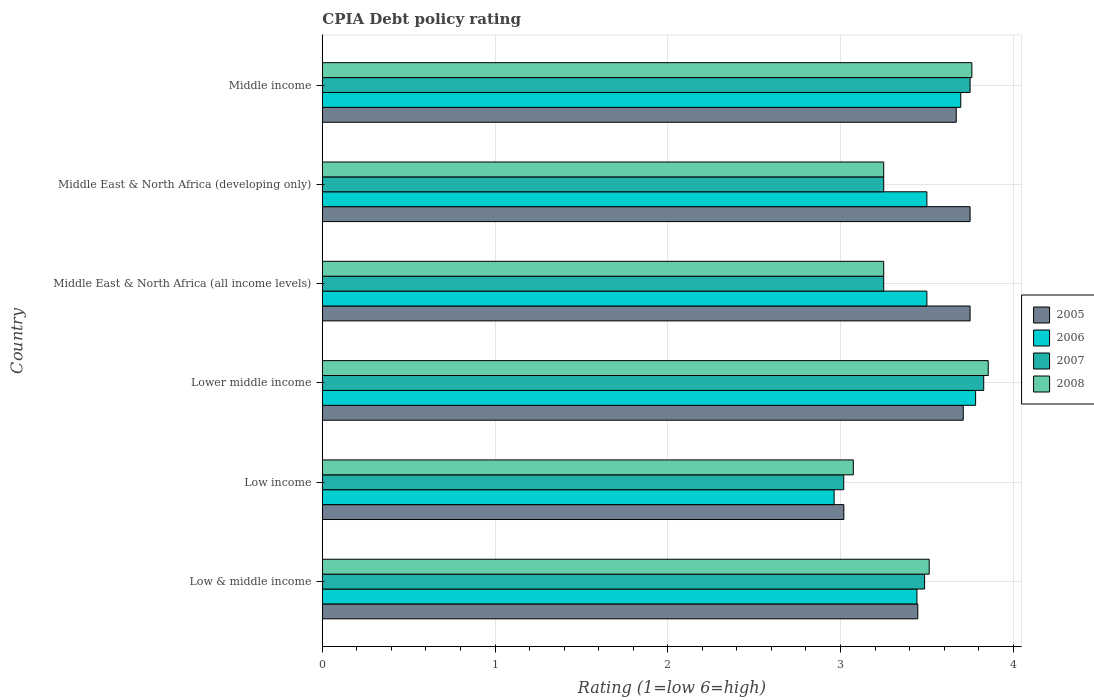How many different coloured bars are there?
Offer a terse response. 4. How many groups of bars are there?
Provide a short and direct response. 6. Are the number of bars per tick equal to the number of legend labels?
Make the answer very short. Yes. How many bars are there on the 2nd tick from the bottom?
Provide a short and direct response. 4. What is the label of the 4th group of bars from the top?
Keep it short and to the point. Lower middle income. What is the CPIA rating in 2005 in Lower middle income?
Keep it short and to the point. 3.71. Across all countries, what is the maximum CPIA rating in 2008?
Ensure brevity in your answer.  3.86. Across all countries, what is the minimum CPIA rating in 2007?
Your answer should be very brief. 3.02. In which country was the CPIA rating in 2008 maximum?
Make the answer very short. Lower middle income. What is the total CPIA rating in 2006 in the graph?
Make the answer very short. 20.88. What is the difference between the CPIA rating in 2007 in Lower middle income and that in Middle East & North Africa (all income levels)?
Your answer should be very brief. 0.58. What is the difference between the CPIA rating in 2005 in Middle East & North Africa (all income levels) and the CPIA rating in 2008 in Low income?
Provide a short and direct response. 0.68. What is the average CPIA rating in 2006 per country?
Provide a short and direct response. 3.48. What is the difference between the CPIA rating in 2007 and CPIA rating in 2008 in Middle East & North Africa (all income levels)?
Your answer should be very brief. 0. What is the ratio of the CPIA rating in 2007 in Low income to that in Middle East & North Africa (all income levels)?
Provide a short and direct response. 0.93. What is the difference between the highest and the second highest CPIA rating in 2005?
Keep it short and to the point. 0. What is the difference between the highest and the lowest CPIA rating in 2007?
Your answer should be very brief. 0.81. In how many countries, is the CPIA rating in 2007 greater than the average CPIA rating in 2007 taken over all countries?
Provide a succinct answer. 3. Is it the case that in every country, the sum of the CPIA rating in 2008 and CPIA rating in 2007 is greater than the CPIA rating in 2006?
Ensure brevity in your answer.  Yes. How many bars are there?
Your answer should be compact. 24. Are all the bars in the graph horizontal?
Provide a succinct answer. Yes. How many countries are there in the graph?
Keep it short and to the point. 6. Are the values on the major ticks of X-axis written in scientific E-notation?
Give a very brief answer. No. Does the graph contain grids?
Offer a very short reply. Yes. Where does the legend appear in the graph?
Make the answer very short. Center right. How many legend labels are there?
Ensure brevity in your answer.  4. How are the legend labels stacked?
Offer a very short reply. Vertical. What is the title of the graph?
Your answer should be compact. CPIA Debt policy rating. Does "2011" appear as one of the legend labels in the graph?
Make the answer very short. No. What is the Rating (1=low 6=high) of 2005 in Low & middle income?
Provide a short and direct response. 3.45. What is the Rating (1=low 6=high) in 2006 in Low & middle income?
Offer a terse response. 3.44. What is the Rating (1=low 6=high) in 2007 in Low & middle income?
Provide a succinct answer. 3.49. What is the Rating (1=low 6=high) in 2008 in Low & middle income?
Keep it short and to the point. 3.51. What is the Rating (1=low 6=high) of 2005 in Low income?
Your response must be concise. 3.02. What is the Rating (1=low 6=high) in 2006 in Low income?
Your answer should be very brief. 2.96. What is the Rating (1=low 6=high) of 2007 in Low income?
Offer a terse response. 3.02. What is the Rating (1=low 6=high) in 2008 in Low income?
Your answer should be very brief. 3.07. What is the Rating (1=low 6=high) of 2005 in Lower middle income?
Keep it short and to the point. 3.71. What is the Rating (1=low 6=high) of 2006 in Lower middle income?
Your answer should be very brief. 3.78. What is the Rating (1=low 6=high) in 2007 in Lower middle income?
Give a very brief answer. 3.83. What is the Rating (1=low 6=high) in 2008 in Lower middle income?
Ensure brevity in your answer.  3.86. What is the Rating (1=low 6=high) in 2005 in Middle East & North Africa (all income levels)?
Provide a short and direct response. 3.75. What is the Rating (1=low 6=high) of 2006 in Middle East & North Africa (all income levels)?
Ensure brevity in your answer.  3.5. What is the Rating (1=low 6=high) in 2007 in Middle East & North Africa (all income levels)?
Make the answer very short. 3.25. What is the Rating (1=low 6=high) of 2008 in Middle East & North Africa (all income levels)?
Give a very brief answer. 3.25. What is the Rating (1=low 6=high) in 2005 in Middle East & North Africa (developing only)?
Offer a very short reply. 3.75. What is the Rating (1=low 6=high) of 2006 in Middle East & North Africa (developing only)?
Keep it short and to the point. 3.5. What is the Rating (1=low 6=high) in 2007 in Middle East & North Africa (developing only)?
Give a very brief answer. 3.25. What is the Rating (1=low 6=high) in 2008 in Middle East & North Africa (developing only)?
Offer a terse response. 3.25. What is the Rating (1=low 6=high) in 2005 in Middle income?
Offer a very short reply. 3.67. What is the Rating (1=low 6=high) of 2006 in Middle income?
Ensure brevity in your answer.  3.7. What is the Rating (1=low 6=high) of 2007 in Middle income?
Offer a very short reply. 3.75. What is the Rating (1=low 6=high) in 2008 in Middle income?
Make the answer very short. 3.76. Across all countries, what is the maximum Rating (1=low 6=high) in 2005?
Your response must be concise. 3.75. Across all countries, what is the maximum Rating (1=low 6=high) of 2006?
Make the answer very short. 3.78. Across all countries, what is the maximum Rating (1=low 6=high) of 2007?
Make the answer very short. 3.83. Across all countries, what is the maximum Rating (1=low 6=high) of 2008?
Your answer should be compact. 3.86. Across all countries, what is the minimum Rating (1=low 6=high) of 2005?
Offer a very short reply. 3.02. Across all countries, what is the minimum Rating (1=low 6=high) in 2006?
Give a very brief answer. 2.96. Across all countries, what is the minimum Rating (1=low 6=high) in 2007?
Your response must be concise. 3.02. Across all countries, what is the minimum Rating (1=low 6=high) of 2008?
Provide a succinct answer. 3.07. What is the total Rating (1=low 6=high) of 2005 in the graph?
Your response must be concise. 21.35. What is the total Rating (1=low 6=high) in 2006 in the graph?
Ensure brevity in your answer.  20.88. What is the total Rating (1=low 6=high) of 2007 in the graph?
Keep it short and to the point. 20.58. What is the total Rating (1=low 6=high) of 2008 in the graph?
Keep it short and to the point. 20.7. What is the difference between the Rating (1=low 6=high) in 2005 in Low & middle income and that in Low income?
Provide a short and direct response. 0.43. What is the difference between the Rating (1=low 6=high) in 2006 in Low & middle income and that in Low income?
Provide a short and direct response. 0.48. What is the difference between the Rating (1=low 6=high) in 2007 in Low & middle income and that in Low income?
Provide a short and direct response. 0.47. What is the difference between the Rating (1=low 6=high) of 2008 in Low & middle income and that in Low income?
Your answer should be compact. 0.44. What is the difference between the Rating (1=low 6=high) of 2005 in Low & middle income and that in Lower middle income?
Keep it short and to the point. -0.26. What is the difference between the Rating (1=low 6=high) in 2006 in Low & middle income and that in Lower middle income?
Your answer should be compact. -0.34. What is the difference between the Rating (1=low 6=high) of 2007 in Low & middle income and that in Lower middle income?
Your answer should be compact. -0.34. What is the difference between the Rating (1=low 6=high) in 2008 in Low & middle income and that in Lower middle income?
Give a very brief answer. -0.34. What is the difference between the Rating (1=low 6=high) in 2005 in Low & middle income and that in Middle East & North Africa (all income levels)?
Provide a succinct answer. -0.3. What is the difference between the Rating (1=low 6=high) in 2006 in Low & middle income and that in Middle East & North Africa (all income levels)?
Offer a very short reply. -0.06. What is the difference between the Rating (1=low 6=high) in 2007 in Low & middle income and that in Middle East & North Africa (all income levels)?
Your answer should be compact. 0.24. What is the difference between the Rating (1=low 6=high) in 2008 in Low & middle income and that in Middle East & North Africa (all income levels)?
Your answer should be compact. 0.26. What is the difference between the Rating (1=low 6=high) of 2005 in Low & middle income and that in Middle East & North Africa (developing only)?
Offer a terse response. -0.3. What is the difference between the Rating (1=low 6=high) of 2006 in Low & middle income and that in Middle East & North Africa (developing only)?
Your answer should be compact. -0.06. What is the difference between the Rating (1=low 6=high) of 2007 in Low & middle income and that in Middle East & North Africa (developing only)?
Offer a very short reply. 0.24. What is the difference between the Rating (1=low 6=high) of 2008 in Low & middle income and that in Middle East & North Africa (developing only)?
Provide a succinct answer. 0.26. What is the difference between the Rating (1=low 6=high) in 2005 in Low & middle income and that in Middle income?
Your answer should be compact. -0.22. What is the difference between the Rating (1=low 6=high) in 2006 in Low & middle income and that in Middle income?
Ensure brevity in your answer.  -0.25. What is the difference between the Rating (1=low 6=high) of 2007 in Low & middle income and that in Middle income?
Your response must be concise. -0.26. What is the difference between the Rating (1=low 6=high) in 2008 in Low & middle income and that in Middle income?
Provide a short and direct response. -0.25. What is the difference between the Rating (1=low 6=high) of 2005 in Low income and that in Lower middle income?
Ensure brevity in your answer.  -0.69. What is the difference between the Rating (1=low 6=high) in 2006 in Low income and that in Lower middle income?
Offer a terse response. -0.82. What is the difference between the Rating (1=low 6=high) of 2007 in Low income and that in Lower middle income?
Give a very brief answer. -0.81. What is the difference between the Rating (1=low 6=high) in 2008 in Low income and that in Lower middle income?
Your answer should be very brief. -0.78. What is the difference between the Rating (1=low 6=high) in 2005 in Low income and that in Middle East & North Africa (all income levels)?
Give a very brief answer. -0.73. What is the difference between the Rating (1=low 6=high) in 2006 in Low income and that in Middle East & North Africa (all income levels)?
Ensure brevity in your answer.  -0.54. What is the difference between the Rating (1=low 6=high) in 2007 in Low income and that in Middle East & North Africa (all income levels)?
Your answer should be very brief. -0.23. What is the difference between the Rating (1=low 6=high) of 2008 in Low income and that in Middle East & North Africa (all income levels)?
Your answer should be very brief. -0.18. What is the difference between the Rating (1=low 6=high) in 2005 in Low income and that in Middle East & North Africa (developing only)?
Provide a succinct answer. -0.73. What is the difference between the Rating (1=low 6=high) of 2006 in Low income and that in Middle East & North Africa (developing only)?
Your response must be concise. -0.54. What is the difference between the Rating (1=low 6=high) in 2007 in Low income and that in Middle East & North Africa (developing only)?
Keep it short and to the point. -0.23. What is the difference between the Rating (1=low 6=high) in 2008 in Low income and that in Middle East & North Africa (developing only)?
Offer a very short reply. -0.18. What is the difference between the Rating (1=low 6=high) in 2005 in Low income and that in Middle income?
Provide a short and direct response. -0.65. What is the difference between the Rating (1=low 6=high) of 2006 in Low income and that in Middle income?
Make the answer very short. -0.73. What is the difference between the Rating (1=low 6=high) of 2007 in Low income and that in Middle income?
Provide a succinct answer. -0.73. What is the difference between the Rating (1=low 6=high) in 2008 in Low income and that in Middle income?
Your answer should be compact. -0.69. What is the difference between the Rating (1=low 6=high) of 2005 in Lower middle income and that in Middle East & North Africa (all income levels)?
Make the answer very short. -0.04. What is the difference between the Rating (1=low 6=high) of 2006 in Lower middle income and that in Middle East & North Africa (all income levels)?
Keep it short and to the point. 0.28. What is the difference between the Rating (1=low 6=high) of 2007 in Lower middle income and that in Middle East & North Africa (all income levels)?
Your answer should be very brief. 0.58. What is the difference between the Rating (1=low 6=high) of 2008 in Lower middle income and that in Middle East & North Africa (all income levels)?
Offer a very short reply. 0.61. What is the difference between the Rating (1=low 6=high) in 2005 in Lower middle income and that in Middle East & North Africa (developing only)?
Your response must be concise. -0.04. What is the difference between the Rating (1=low 6=high) in 2006 in Lower middle income and that in Middle East & North Africa (developing only)?
Provide a succinct answer. 0.28. What is the difference between the Rating (1=low 6=high) of 2007 in Lower middle income and that in Middle East & North Africa (developing only)?
Make the answer very short. 0.58. What is the difference between the Rating (1=low 6=high) in 2008 in Lower middle income and that in Middle East & North Africa (developing only)?
Keep it short and to the point. 0.61. What is the difference between the Rating (1=low 6=high) of 2005 in Lower middle income and that in Middle income?
Ensure brevity in your answer.  0.04. What is the difference between the Rating (1=low 6=high) of 2006 in Lower middle income and that in Middle income?
Provide a short and direct response. 0.09. What is the difference between the Rating (1=low 6=high) in 2007 in Lower middle income and that in Middle income?
Keep it short and to the point. 0.08. What is the difference between the Rating (1=low 6=high) in 2008 in Lower middle income and that in Middle income?
Make the answer very short. 0.09. What is the difference between the Rating (1=low 6=high) in 2005 in Middle East & North Africa (all income levels) and that in Middle East & North Africa (developing only)?
Your answer should be compact. 0. What is the difference between the Rating (1=low 6=high) in 2008 in Middle East & North Africa (all income levels) and that in Middle East & North Africa (developing only)?
Your response must be concise. 0. What is the difference between the Rating (1=low 6=high) in 2005 in Middle East & North Africa (all income levels) and that in Middle income?
Give a very brief answer. 0.08. What is the difference between the Rating (1=low 6=high) of 2006 in Middle East & North Africa (all income levels) and that in Middle income?
Provide a short and direct response. -0.2. What is the difference between the Rating (1=low 6=high) in 2007 in Middle East & North Africa (all income levels) and that in Middle income?
Provide a short and direct response. -0.5. What is the difference between the Rating (1=low 6=high) of 2008 in Middle East & North Africa (all income levels) and that in Middle income?
Ensure brevity in your answer.  -0.51. What is the difference between the Rating (1=low 6=high) of 2006 in Middle East & North Africa (developing only) and that in Middle income?
Your answer should be compact. -0.2. What is the difference between the Rating (1=low 6=high) in 2007 in Middle East & North Africa (developing only) and that in Middle income?
Keep it short and to the point. -0.5. What is the difference between the Rating (1=low 6=high) in 2008 in Middle East & North Africa (developing only) and that in Middle income?
Offer a very short reply. -0.51. What is the difference between the Rating (1=low 6=high) in 2005 in Low & middle income and the Rating (1=low 6=high) in 2006 in Low income?
Make the answer very short. 0.48. What is the difference between the Rating (1=low 6=high) in 2005 in Low & middle income and the Rating (1=low 6=high) in 2007 in Low income?
Provide a short and direct response. 0.43. What is the difference between the Rating (1=low 6=high) in 2005 in Low & middle income and the Rating (1=low 6=high) in 2008 in Low income?
Your answer should be very brief. 0.37. What is the difference between the Rating (1=low 6=high) of 2006 in Low & middle income and the Rating (1=low 6=high) of 2007 in Low income?
Your answer should be very brief. 0.42. What is the difference between the Rating (1=low 6=high) of 2006 in Low & middle income and the Rating (1=low 6=high) of 2008 in Low income?
Provide a short and direct response. 0.37. What is the difference between the Rating (1=low 6=high) of 2007 in Low & middle income and the Rating (1=low 6=high) of 2008 in Low income?
Give a very brief answer. 0.41. What is the difference between the Rating (1=low 6=high) of 2005 in Low & middle income and the Rating (1=low 6=high) of 2006 in Lower middle income?
Your answer should be compact. -0.33. What is the difference between the Rating (1=low 6=high) of 2005 in Low & middle income and the Rating (1=low 6=high) of 2007 in Lower middle income?
Give a very brief answer. -0.38. What is the difference between the Rating (1=low 6=high) in 2005 in Low & middle income and the Rating (1=low 6=high) in 2008 in Lower middle income?
Offer a very short reply. -0.41. What is the difference between the Rating (1=low 6=high) of 2006 in Low & middle income and the Rating (1=low 6=high) of 2007 in Lower middle income?
Keep it short and to the point. -0.39. What is the difference between the Rating (1=low 6=high) in 2006 in Low & middle income and the Rating (1=low 6=high) in 2008 in Lower middle income?
Your response must be concise. -0.41. What is the difference between the Rating (1=low 6=high) in 2007 in Low & middle income and the Rating (1=low 6=high) in 2008 in Lower middle income?
Offer a terse response. -0.37. What is the difference between the Rating (1=low 6=high) of 2005 in Low & middle income and the Rating (1=low 6=high) of 2006 in Middle East & North Africa (all income levels)?
Provide a succinct answer. -0.05. What is the difference between the Rating (1=low 6=high) of 2005 in Low & middle income and the Rating (1=low 6=high) of 2007 in Middle East & North Africa (all income levels)?
Make the answer very short. 0.2. What is the difference between the Rating (1=low 6=high) in 2005 in Low & middle income and the Rating (1=low 6=high) in 2008 in Middle East & North Africa (all income levels)?
Provide a succinct answer. 0.2. What is the difference between the Rating (1=low 6=high) in 2006 in Low & middle income and the Rating (1=low 6=high) in 2007 in Middle East & North Africa (all income levels)?
Provide a short and direct response. 0.19. What is the difference between the Rating (1=low 6=high) of 2006 in Low & middle income and the Rating (1=low 6=high) of 2008 in Middle East & North Africa (all income levels)?
Provide a short and direct response. 0.19. What is the difference between the Rating (1=low 6=high) in 2007 in Low & middle income and the Rating (1=low 6=high) in 2008 in Middle East & North Africa (all income levels)?
Make the answer very short. 0.24. What is the difference between the Rating (1=low 6=high) in 2005 in Low & middle income and the Rating (1=low 6=high) in 2006 in Middle East & North Africa (developing only)?
Your response must be concise. -0.05. What is the difference between the Rating (1=low 6=high) of 2005 in Low & middle income and the Rating (1=low 6=high) of 2007 in Middle East & North Africa (developing only)?
Your answer should be very brief. 0.2. What is the difference between the Rating (1=low 6=high) of 2005 in Low & middle income and the Rating (1=low 6=high) of 2008 in Middle East & North Africa (developing only)?
Offer a terse response. 0.2. What is the difference between the Rating (1=low 6=high) in 2006 in Low & middle income and the Rating (1=low 6=high) in 2007 in Middle East & North Africa (developing only)?
Your answer should be compact. 0.19. What is the difference between the Rating (1=low 6=high) in 2006 in Low & middle income and the Rating (1=low 6=high) in 2008 in Middle East & North Africa (developing only)?
Keep it short and to the point. 0.19. What is the difference between the Rating (1=low 6=high) of 2007 in Low & middle income and the Rating (1=low 6=high) of 2008 in Middle East & North Africa (developing only)?
Offer a very short reply. 0.24. What is the difference between the Rating (1=low 6=high) in 2005 in Low & middle income and the Rating (1=low 6=high) in 2006 in Middle income?
Provide a succinct answer. -0.25. What is the difference between the Rating (1=low 6=high) in 2005 in Low & middle income and the Rating (1=low 6=high) in 2007 in Middle income?
Provide a short and direct response. -0.3. What is the difference between the Rating (1=low 6=high) in 2005 in Low & middle income and the Rating (1=low 6=high) in 2008 in Middle income?
Ensure brevity in your answer.  -0.31. What is the difference between the Rating (1=low 6=high) of 2006 in Low & middle income and the Rating (1=low 6=high) of 2007 in Middle income?
Your response must be concise. -0.31. What is the difference between the Rating (1=low 6=high) in 2006 in Low & middle income and the Rating (1=low 6=high) in 2008 in Middle income?
Make the answer very short. -0.32. What is the difference between the Rating (1=low 6=high) of 2007 in Low & middle income and the Rating (1=low 6=high) of 2008 in Middle income?
Your answer should be compact. -0.27. What is the difference between the Rating (1=low 6=high) of 2005 in Low income and the Rating (1=low 6=high) of 2006 in Lower middle income?
Make the answer very short. -0.76. What is the difference between the Rating (1=low 6=high) in 2005 in Low income and the Rating (1=low 6=high) in 2007 in Lower middle income?
Keep it short and to the point. -0.81. What is the difference between the Rating (1=low 6=high) in 2005 in Low income and the Rating (1=low 6=high) in 2008 in Lower middle income?
Your answer should be very brief. -0.84. What is the difference between the Rating (1=low 6=high) in 2006 in Low income and the Rating (1=low 6=high) in 2007 in Lower middle income?
Your answer should be compact. -0.87. What is the difference between the Rating (1=low 6=high) in 2006 in Low income and the Rating (1=low 6=high) in 2008 in Lower middle income?
Make the answer very short. -0.89. What is the difference between the Rating (1=low 6=high) in 2007 in Low income and the Rating (1=low 6=high) in 2008 in Lower middle income?
Provide a short and direct response. -0.84. What is the difference between the Rating (1=low 6=high) of 2005 in Low income and the Rating (1=low 6=high) of 2006 in Middle East & North Africa (all income levels)?
Give a very brief answer. -0.48. What is the difference between the Rating (1=low 6=high) in 2005 in Low income and the Rating (1=low 6=high) in 2007 in Middle East & North Africa (all income levels)?
Your response must be concise. -0.23. What is the difference between the Rating (1=low 6=high) in 2005 in Low income and the Rating (1=low 6=high) in 2008 in Middle East & North Africa (all income levels)?
Provide a short and direct response. -0.23. What is the difference between the Rating (1=low 6=high) in 2006 in Low income and the Rating (1=low 6=high) in 2007 in Middle East & North Africa (all income levels)?
Ensure brevity in your answer.  -0.29. What is the difference between the Rating (1=low 6=high) of 2006 in Low income and the Rating (1=low 6=high) of 2008 in Middle East & North Africa (all income levels)?
Offer a very short reply. -0.29. What is the difference between the Rating (1=low 6=high) of 2007 in Low income and the Rating (1=low 6=high) of 2008 in Middle East & North Africa (all income levels)?
Your answer should be very brief. -0.23. What is the difference between the Rating (1=low 6=high) in 2005 in Low income and the Rating (1=low 6=high) in 2006 in Middle East & North Africa (developing only)?
Offer a terse response. -0.48. What is the difference between the Rating (1=low 6=high) of 2005 in Low income and the Rating (1=low 6=high) of 2007 in Middle East & North Africa (developing only)?
Your response must be concise. -0.23. What is the difference between the Rating (1=low 6=high) in 2005 in Low income and the Rating (1=low 6=high) in 2008 in Middle East & North Africa (developing only)?
Offer a very short reply. -0.23. What is the difference between the Rating (1=low 6=high) in 2006 in Low income and the Rating (1=low 6=high) in 2007 in Middle East & North Africa (developing only)?
Your answer should be very brief. -0.29. What is the difference between the Rating (1=low 6=high) in 2006 in Low income and the Rating (1=low 6=high) in 2008 in Middle East & North Africa (developing only)?
Your answer should be very brief. -0.29. What is the difference between the Rating (1=low 6=high) of 2007 in Low income and the Rating (1=low 6=high) of 2008 in Middle East & North Africa (developing only)?
Offer a very short reply. -0.23. What is the difference between the Rating (1=low 6=high) of 2005 in Low income and the Rating (1=low 6=high) of 2006 in Middle income?
Give a very brief answer. -0.68. What is the difference between the Rating (1=low 6=high) of 2005 in Low income and the Rating (1=low 6=high) of 2007 in Middle income?
Ensure brevity in your answer.  -0.73. What is the difference between the Rating (1=low 6=high) of 2005 in Low income and the Rating (1=low 6=high) of 2008 in Middle income?
Your answer should be very brief. -0.74. What is the difference between the Rating (1=low 6=high) of 2006 in Low income and the Rating (1=low 6=high) of 2007 in Middle income?
Provide a short and direct response. -0.79. What is the difference between the Rating (1=low 6=high) in 2006 in Low income and the Rating (1=low 6=high) in 2008 in Middle income?
Make the answer very short. -0.8. What is the difference between the Rating (1=low 6=high) of 2007 in Low income and the Rating (1=low 6=high) of 2008 in Middle income?
Offer a very short reply. -0.74. What is the difference between the Rating (1=low 6=high) of 2005 in Lower middle income and the Rating (1=low 6=high) of 2006 in Middle East & North Africa (all income levels)?
Give a very brief answer. 0.21. What is the difference between the Rating (1=low 6=high) in 2005 in Lower middle income and the Rating (1=low 6=high) in 2007 in Middle East & North Africa (all income levels)?
Make the answer very short. 0.46. What is the difference between the Rating (1=low 6=high) in 2005 in Lower middle income and the Rating (1=low 6=high) in 2008 in Middle East & North Africa (all income levels)?
Provide a short and direct response. 0.46. What is the difference between the Rating (1=low 6=high) in 2006 in Lower middle income and the Rating (1=low 6=high) in 2007 in Middle East & North Africa (all income levels)?
Your answer should be very brief. 0.53. What is the difference between the Rating (1=low 6=high) of 2006 in Lower middle income and the Rating (1=low 6=high) of 2008 in Middle East & North Africa (all income levels)?
Your response must be concise. 0.53. What is the difference between the Rating (1=low 6=high) of 2007 in Lower middle income and the Rating (1=low 6=high) of 2008 in Middle East & North Africa (all income levels)?
Keep it short and to the point. 0.58. What is the difference between the Rating (1=low 6=high) in 2005 in Lower middle income and the Rating (1=low 6=high) in 2006 in Middle East & North Africa (developing only)?
Give a very brief answer. 0.21. What is the difference between the Rating (1=low 6=high) in 2005 in Lower middle income and the Rating (1=low 6=high) in 2007 in Middle East & North Africa (developing only)?
Keep it short and to the point. 0.46. What is the difference between the Rating (1=low 6=high) in 2005 in Lower middle income and the Rating (1=low 6=high) in 2008 in Middle East & North Africa (developing only)?
Offer a terse response. 0.46. What is the difference between the Rating (1=low 6=high) of 2006 in Lower middle income and the Rating (1=low 6=high) of 2007 in Middle East & North Africa (developing only)?
Your response must be concise. 0.53. What is the difference between the Rating (1=low 6=high) in 2006 in Lower middle income and the Rating (1=low 6=high) in 2008 in Middle East & North Africa (developing only)?
Offer a very short reply. 0.53. What is the difference between the Rating (1=low 6=high) of 2007 in Lower middle income and the Rating (1=low 6=high) of 2008 in Middle East & North Africa (developing only)?
Keep it short and to the point. 0.58. What is the difference between the Rating (1=low 6=high) of 2005 in Lower middle income and the Rating (1=low 6=high) of 2006 in Middle income?
Your response must be concise. 0.01. What is the difference between the Rating (1=low 6=high) of 2005 in Lower middle income and the Rating (1=low 6=high) of 2007 in Middle income?
Your answer should be very brief. -0.04. What is the difference between the Rating (1=low 6=high) in 2005 in Lower middle income and the Rating (1=low 6=high) in 2008 in Middle income?
Your answer should be compact. -0.05. What is the difference between the Rating (1=low 6=high) in 2006 in Lower middle income and the Rating (1=low 6=high) in 2007 in Middle income?
Ensure brevity in your answer.  0.03. What is the difference between the Rating (1=low 6=high) in 2006 in Lower middle income and the Rating (1=low 6=high) in 2008 in Middle income?
Your answer should be compact. 0.02. What is the difference between the Rating (1=low 6=high) of 2007 in Lower middle income and the Rating (1=low 6=high) of 2008 in Middle income?
Your answer should be compact. 0.07. What is the difference between the Rating (1=low 6=high) of 2005 in Middle East & North Africa (all income levels) and the Rating (1=low 6=high) of 2008 in Middle East & North Africa (developing only)?
Ensure brevity in your answer.  0.5. What is the difference between the Rating (1=low 6=high) of 2005 in Middle East & North Africa (all income levels) and the Rating (1=low 6=high) of 2006 in Middle income?
Provide a succinct answer. 0.05. What is the difference between the Rating (1=low 6=high) of 2005 in Middle East & North Africa (all income levels) and the Rating (1=low 6=high) of 2008 in Middle income?
Make the answer very short. -0.01. What is the difference between the Rating (1=low 6=high) of 2006 in Middle East & North Africa (all income levels) and the Rating (1=low 6=high) of 2008 in Middle income?
Offer a terse response. -0.26. What is the difference between the Rating (1=low 6=high) of 2007 in Middle East & North Africa (all income levels) and the Rating (1=low 6=high) of 2008 in Middle income?
Give a very brief answer. -0.51. What is the difference between the Rating (1=low 6=high) of 2005 in Middle East & North Africa (developing only) and the Rating (1=low 6=high) of 2006 in Middle income?
Ensure brevity in your answer.  0.05. What is the difference between the Rating (1=low 6=high) in 2005 in Middle East & North Africa (developing only) and the Rating (1=low 6=high) in 2008 in Middle income?
Your response must be concise. -0.01. What is the difference between the Rating (1=low 6=high) of 2006 in Middle East & North Africa (developing only) and the Rating (1=low 6=high) of 2008 in Middle income?
Provide a succinct answer. -0.26. What is the difference between the Rating (1=low 6=high) in 2007 in Middle East & North Africa (developing only) and the Rating (1=low 6=high) in 2008 in Middle income?
Make the answer very short. -0.51. What is the average Rating (1=low 6=high) of 2005 per country?
Make the answer very short. 3.56. What is the average Rating (1=low 6=high) of 2006 per country?
Make the answer very short. 3.48. What is the average Rating (1=low 6=high) in 2007 per country?
Provide a short and direct response. 3.43. What is the average Rating (1=low 6=high) of 2008 per country?
Your answer should be compact. 3.45. What is the difference between the Rating (1=low 6=high) of 2005 and Rating (1=low 6=high) of 2006 in Low & middle income?
Provide a short and direct response. 0.01. What is the difference between the Rating (1=low 6=high) of 2005 and Rating (1=low 6=high) of 2007 in Low & middle income?
Give a very brief answer. -0.04. What is the difference between the Rating (1=low 6=high) of 2005 and Rating (1=low 6=high) of 2008 in Low & middle income?
Give a very brief answer. -0.07. What is the difference between the Rating (1=low 6=high) in 2006 and Rating (1=low 6=high) in 2007 in Low & middle income?
Your answer should be compact. -0.04. What is the difference between the Rating (1=low 6=high) of 2006 and Rating (1=low 6=high) of 2008 in Low & middle income?
Keep it short and to the point. -0.07. What is the difference between the Rating (1=low 6=high) of 2007 and Rating (1=low 6=high) of 2008 in Low & middle income?
Provide a succinct answer. -0.03. What is the difference between the Rating (1=low 6=high) of 2005 and Rating (1=low 6=high) of 2006 in Low income?
Your response must be concise. 0.06. What is the difference between the Rating (1=low 6=high) of 2005 and Rating (1=low 6=high) of 2007 in Low income?
Provide a succinct answer. 0. What is the difference between the Rating (1=low 6=high) of 2005 and Rating (1=low 6=high) of 2008 in Low income?
Your response must be concise. -0.05. What is the difference between the Rating (1=low 6=high) in 2006 and Rating (1=low 6=high) in 2007 in Low income?
Your answer should be compact. -0.06. What is the difference between the Rating (1=low 6=high) of 2006 and Rating (1=low 6=high) of 2008 in Low income?
Your answer should be very brief. -0.11. What is the difference between the Rating (1=low 6=high) in 2007 and Rating (1=low 6=high) in 2008 in Low income?
Ensure brevity in your answer.  -0.06. What is the difference between the Rating (1=low 6=high) of 2005 and Rating (1=low 6=high) of 2006 in Lower middle income?
Make the answer very short. -0.07. What is the difference between the Rating (1=low 6=high) in 2005 and Rating (1=low 6=high) in 2007 in Lower middle income?
Your answer should be compact. -0.12. What is the difference between the Rating (1=low 6=high) in 2005 and Rating (1=low 6=high) in 2008 in Lower middle income?
Offer a terse response. -0.14. What is the difference between the Rating (1=low 6=high) in 2006 and Rating (1=low 6=high) in 2007 in Lower middle income?
Ensure brevity in your answer.  -0.05. What is the difference between the Rating (1=low 6=high) of 2006 and Rating (1=low 6=high) of 2008 in Lower middle income?
Ensure brevity in your answer.  -0.07. What is the difference between the Rating (1=low 6=high) of 2007 and Rating (1=low 6=high) of 2008 in Lower middle income?
Provide a short and direct response. -0.03. What is the difference between the Rating (1=low 6=high) of 2005 and Rating (1=low 6=high) of 2008 in Middle East & North Africa (all income levels)?
Make the answer very short. 0.5. What is the difference between the Rating (1=low 6=high) of 2005 and Rating (1=low 6=high) of 2006 in Middle East & North Africa (developing only)?
Your response must be concise. 0.25. What is the difference between the Rating (1=low 6=high) of 2005 and Rating (1=low 6=high) of 2007 in Middle East & North Africa (developing only)?
Your answer should be compact. 0.5. What is the difference between the Rating (1=low 6=high) of 2007 and Rating (1=low 6=high) of 2008 in Middle East & North Africa (developing only)?
Make the answer very short. 0. What is the difference between the Rating (1=low 6=high) in 2005 and Rating (1=low 6=high) in 2006 in Middle income?
Give a very brief answer. -0.03. What is the difference between the Rating (1=low 6=high) in 2005 and Rating (1=low 6=high) in 2007 in Middle income?
Keep it short and to the point. -0.08. What is the difference between the Rating (1=low 6=high) in 2005 and Rating (1=low 6=high) in 2008 in Middle income?
Make the answer very short. -0.09. What is the difference between the Rating (1=low 6=high) in 2006 and Rating (1=low 6=high) in 2007 in Middle income?
Keep it short and to the point. -0.05. What is the difference between the Rating (1=low 6=high) in 2006 and Rating (1=low 6=high) in 2008 in Middle income?
Provide a short and direct response. -0.06. What is the difference between the Rating (1=low 6=high) of 2007 and Rating (1=low 6=high) of 2008 in Middle income?
Make the answer very short. -0.01. What is the ratio of the Rating (1=low 6=high) in 2005 in Low & middle income to that in Low income?
Ensure brevity in your answer.  1.14. What is the ratio of the Rating (1=low 6=high) of 2006 in Low & middle income to that in Low income?
Offer a terse response. 1.16. What is the ratio of the Rating (1=low 6=high) in 2007 in Low & middle income to that in Low income?
Keep it short and to the point. 1.16. What is the ratio of the Rating (1=low 6=high) of 2005 in Low & middle income to that in Lower middle income?
Your answer should be compact. 0.93. What is the ratio of the Rating (1=low 6=high) in 2006 in Low & middle income to that in Lower middle income?
Keep it short and to the point. 0.91. What is the ratio of the Rating (1=low 6=high) of 2007 in Low & middle income to that in Lower middle income?
Provide a short and direct response. 0.91. What is the ratio of the Rating (1=low 6=high) in 2008 in Low & middle income to that in Lower middle income?
Provide a short and direct response. 0.91. What is the ratio of the Rating (1=low 6=high) of 2005 in Low & middle income to that in Middle East & North Africa (all income levels)?
Provide a short and direct response. 0.92. What is the ratio of the Rating (1=low 6=high) in 2006 in Low & middle income to that in Middle East & North Africa (all income levels)?
Your answer should be very brief. 0.98. What is the ratio of the Rating (1=low 6=high) of 2007 in Low & middle income to that in Middle East & North Africa (all income levels)?
Your response must be concise. 1.07. What is the ratio of the Rating (1=low 6=high) in 2008 in Low & middle income to that in Middle East & North Africa (all income levels)?
Offer a very short reply. 1.08. What is the ratio of the Rating (1=low 6=high) in 2005 in Low & middle income to that in Middle East & North Africa (developing only)?
Offer a very short reply. 0.92. What is the ratio of the Rating (1=low 6=high) in 2006 in Low & middle income to that in Middle East & North Africa (developing only)?
Provide a succinct answer. 0.98. What is the ratio of the Rating (1=low 6=high) of 2007 in Low & middle income to that in Middle East & North Africa (developing only)?
Your response must be concise. 1.07. What is the ratio of the Rating (1=low 6=high) in 2008 in Low & middle income to that in Middle East & North Africa (developing only)?
Your response must be concise. 1.08. What is the ratio of the Rating (1=low 6=high) of 2005 in Low & middle income to that in Middle income?
Offer a very short reply. 0.94. What is the ratio of the Rating (1=low 6=high) of 2006 in Low & middle income to that in Middle income?
Make the answer very short. 0.93. What is the ratio of the Rating (1=low 6=high) of 2007 in Low & middle income to that in Middle income?
Give a very brief answer. 0.93. What is the ratio of the Rating (1=low 6=high) in 2008 in Low & middle income to that in Middle income?
Ensure brevity in your answer.  0.93. What is the ratio of the Rating (1=low 6=high) of 2005 in Low income to that in Lower middle income?
Offer a very short reply. 0.81. What is the ratio of the Rating (1=low 6=high) in 2006 in Low income to that in Lower middle income?
Provide a succinct answer. 0.78. What is the ratio of the Rating (1=low 6=high) in 2007 in Low income to that in Lower middle income?
Your answer should be very brief. 0.79. What is the ratio of the Rating (1=low 6=high) in 2008 in Low income to that in Lower middle income?
Offer a very short reply. 0.8. What is the ratio of the Rating (1=low 6=high) in 2005 in Low income to that in Middle East & North Africa (all income levels)?
Ensure brevity in your answer.  0.81. What is the ratio of the Rating (1=low 6=high) of 2006 in Low income to that in Middle East & North Africa (all income levels)?
Your response must be concise. 0.85. What is the ratio of the Rating (1=low 6=high) of 2007 in Low income to that in Middle East & North Africa (all income levels)?
Offer a terse response. 0.93. What is the ratio of the Rating (1=low 6=high) of 2008 in Low income to that in Middle East & North Africa (all income levels)?
Make the answer very short. 0.95. What is the ratio of the Rating (1=low 6=high) in 2005 in Low income to that in Middle East & North Africa (developing only)?
Your response must be concise. 0.81. What is the ratio of the Rating (1=low 6=high) of 2006 in Low income to that in Middle East & North Africa (developing only)?
Your answer should be compact. 0.85. What is the ratio of the Rating (1=low 6=high) of 2007 in Low income to that in Middle East & North Africa (developing only)?
Ensure brevity in your answer.  0.93. What is the ratio of the Rating (1=low 6=high) in 2008 in Low income to that in Middle East & North Africa (developing only)?
Provide a short and direct response. 0.95. What is the ratio of the Rating (1=low 6=high) of 2005 in Low income to that in Middle income?
Ensure brevity in your answer.  0.82. What is the ratio of the Rating (1=low 6=high) in 2006 in Low income to that in Middle income?
Keep it short and to the point. 0.8. What is the ratio of the Rating (1=low 6=high) of 2007 in Low income to that in Middle income?
Make the answer very short. 0.8. What is the ratio of the Rating (1=low 6=high) of 2008 in Low income to that in Middle income?
Offer a terse response. 0.82. What is the ratio of the Rating (1=low 6=high) of 2005 in Lower middle income to that in Middle East & North Africa (all income levels)?
Ensure brevity in your answer.  0.99. What is the ratio of the Rating (1=low 6=high) of 2006 in Lower middle income to that in Middle East & North Africa (all income levels)?
Your answer should be very brief. 1.08. What is the ratio of the Rating (1=low 6=high) of 2007 in Lower middle income to that in Middle East & North Africa (all income levels)?
Offer a terse response. 1.18. What is the ratio of the Rating (1=low 6=high) of 2008 in Lower middle income to that in Middle East & North Africa (all income levels)?
Your answer should be compact. 1.19. What is the ratio of the Rating (1=low 6=high) of 2005 in Lower middle income to that in Middle East & North Africa (developing only)?
Provide a short and direct response. 0.99. What is the ratio of the Rating (1=low 6=high) of 2006 in Lower middle income to that in Middle East & North Africa (developing only)?
Provide a short and direct response. 1.08. What is the ratio of the Rating (1=low 6=high) in 2007 in Lower middle income to that in Middle East & North Africa (developing only)?
Your response must be concise. 1.18. What is the ratio of the Rating (1=low 6=high) in 2008 in Lower middle income to that in Middle East & North Africa (developing only)?
Keep it short and to the point. 1.19. What is the ratio of the Rating (1=low 6=high) in 2006 in Lower middle income to that in Middle income?
Your answer should be very brief. 1.02. What is the ratio of the Rating (1=low 6=high) of 2007 in Lower middle income to that in Middle income?
Your answer should be compact. 1.02. What is the ratio of the Rating (1=low 6=high) in 2008 in Lower middle income to that in Middle income?
Make the answer very short. 1.03. What is the ratio of the Rating (1=low 6=high) of 2005 in Middle East & North Africa (all income levels) to that in Middle East & North Africa (developing only)?
Keep it short and to the point. 1. What is the ratio of the Rating (1=low 6=high) of 2006 in Middle East & North Africa (all income levels) to that in Middle East & North Africa (developing only)?
Give a very brief answer. 1. What is the ratio of the Rating (1=low 6=high) of 2008 in Middle East & North Africa (all income levels) to that in Middle East & North Africa (developing only)?
Your answer should be very brief. 1. What is the ratio of the Rating (1=low 6=high) in 2005 in Middle East & North Africa (all income levels) to that in Middle income?
Your answer should be compact. 1.02. What is the ratio of the Rating (1=low 6=high) of 2006 in Middle East & North Africa (all income levels) to that in Middle income?
Ensure brevity in your answer.  0.95. What is the ratio of the Rating (1=low 6=high) in 2007 in Middle East & North Africa (all income levels) to that in Middle income?
Give a very brief answer. 0.87. What is the ratio of the Rating (1=low 6=high) of 2008 in Middle East & North Africa (all income levels) to that in Middle income?
Make the answer very short. 0.86. What is the ratio of the Rating (1=low 6=high) of 2005 in Middle East & North Africa (developing only) to that in Middle income?
Provide a succinct answer. 1.02. What is the ratio of the Rating (1=low 6=high) in 2006 in Middle East & North Africa (developing only) to that in Middle income?
Your answer should be compact. 0.95. What is the ratio of the Rating (1=low 6=high) in 2007 in Middle East & North Africa (developing only) to that in Middle income?
Your answer should be compact. 0.87. What is the ratio of the Rating (1=low 6=high) in 2008 in Middle East & North Africa (developing only) to that in Middle income?
Your response must be concise. 0.86. What is the difference between the highest and the second highest Rating (1=low 6=high) of 2006?
Make the answer very short. 0.09. What is the difference between the highest and the second highest Rating (1=low 6=high) in 2007?
Your answer should be very brief. 0.08. What is the difference between the highest and the second highest Rating (1=low 6=high) in 2008?
Your answer should be very brief. 0.09. What is the difference between the highest and the lowest Rating (1=low 6=high) in 2005?
Offer a terse response. 0.73. What is the difference between the highest and the lowest Rating (1=low 6=high) of 2006?
Keep it short and to the point. 0.82. What is the difference between the highest and the lowest Rating (1=low 6=high) of 2007?
Your answer should be very brief. 0.81. What is the difference between the highest and the lowest Rating (1=low 6=high) in 2008?
Give a very brief answer. 0.78. 